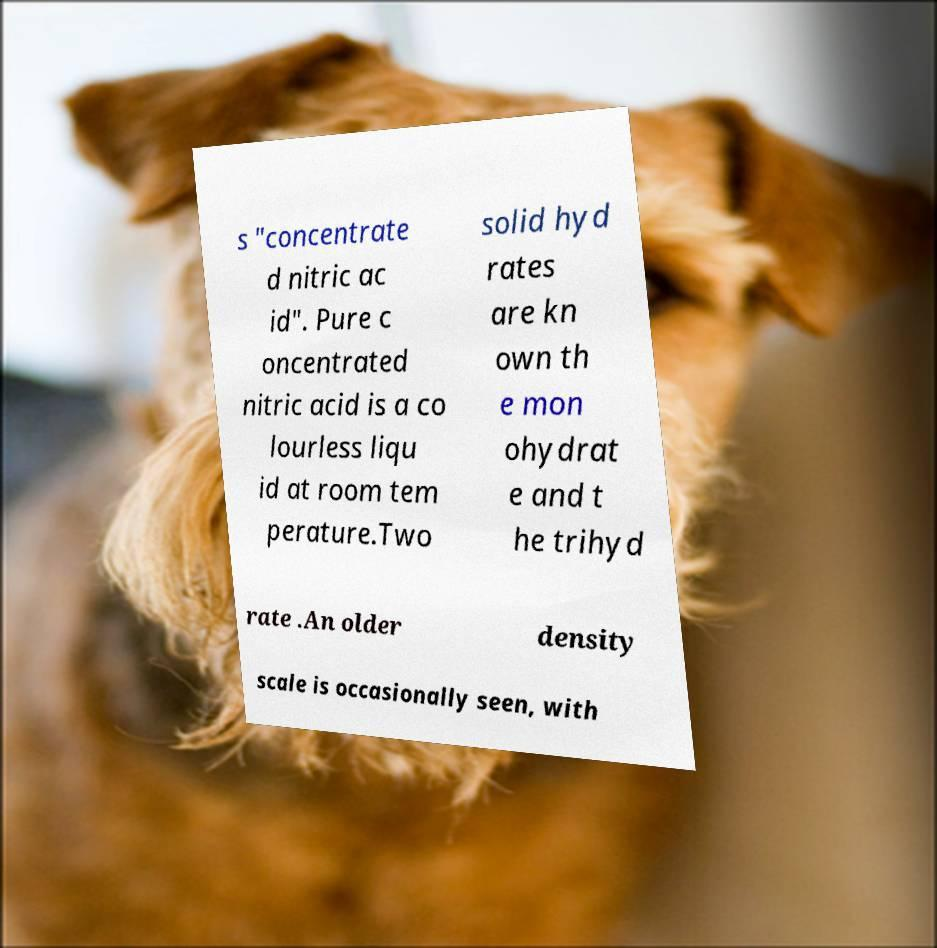What messages or text are displayed in this image? I need them in a readable, typed format. s "concentrate d nitric ac id". Pure c oncentrated nitric acid is a co lourless liqu id at room tem perature.Two solid hyd rates are kn own th e mon ohydrat e and t he trihyd rate .An older density scale is occasionally seen, with 